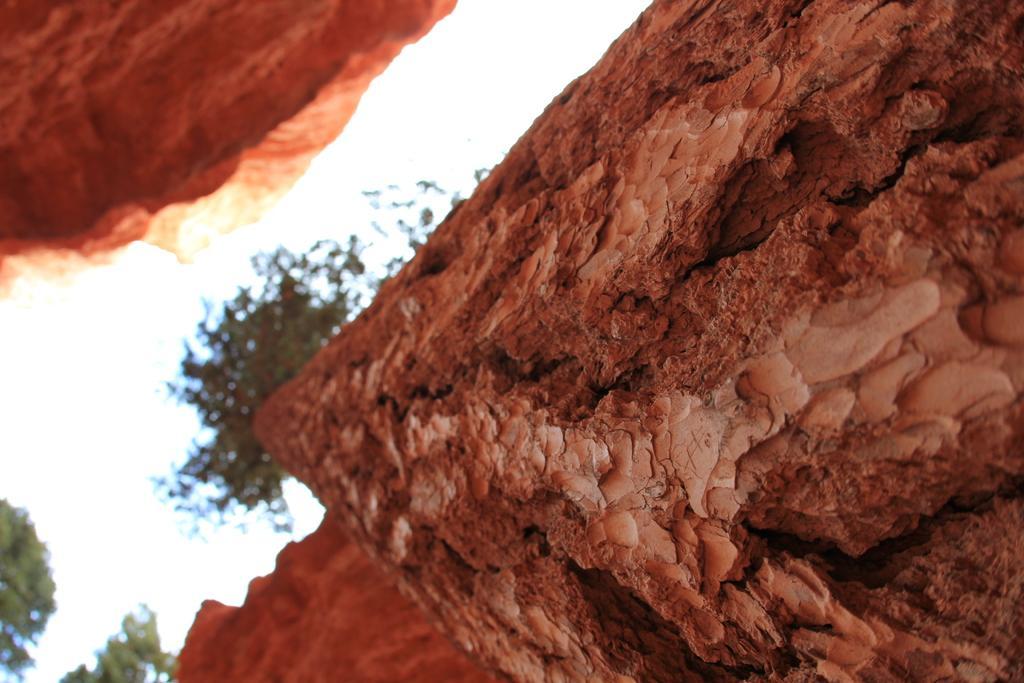Describe this image in one or two sentences. In this image we can see the bark of a tree. We can also see some trees and the sky which looks cloudy. 